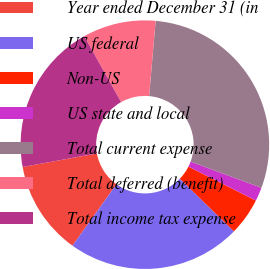Convert chart. <chart><loc_0><loc_0><loc_500><loc_500><pie_chart><fcel>Year ended December 31 (in<fcel>US federal<fcel>Non-US<fcel>US state and local<fcel>Total current expense<fcel>Total deferred (benefit)<fcel>Total income tax expense<nl><fcel>12.23%<fcel>22.61%<fcel>4.86%<fcel>1.79%<fcel>29.26%<fcel>9.49%<fcel>19.77%<nl></chart> 